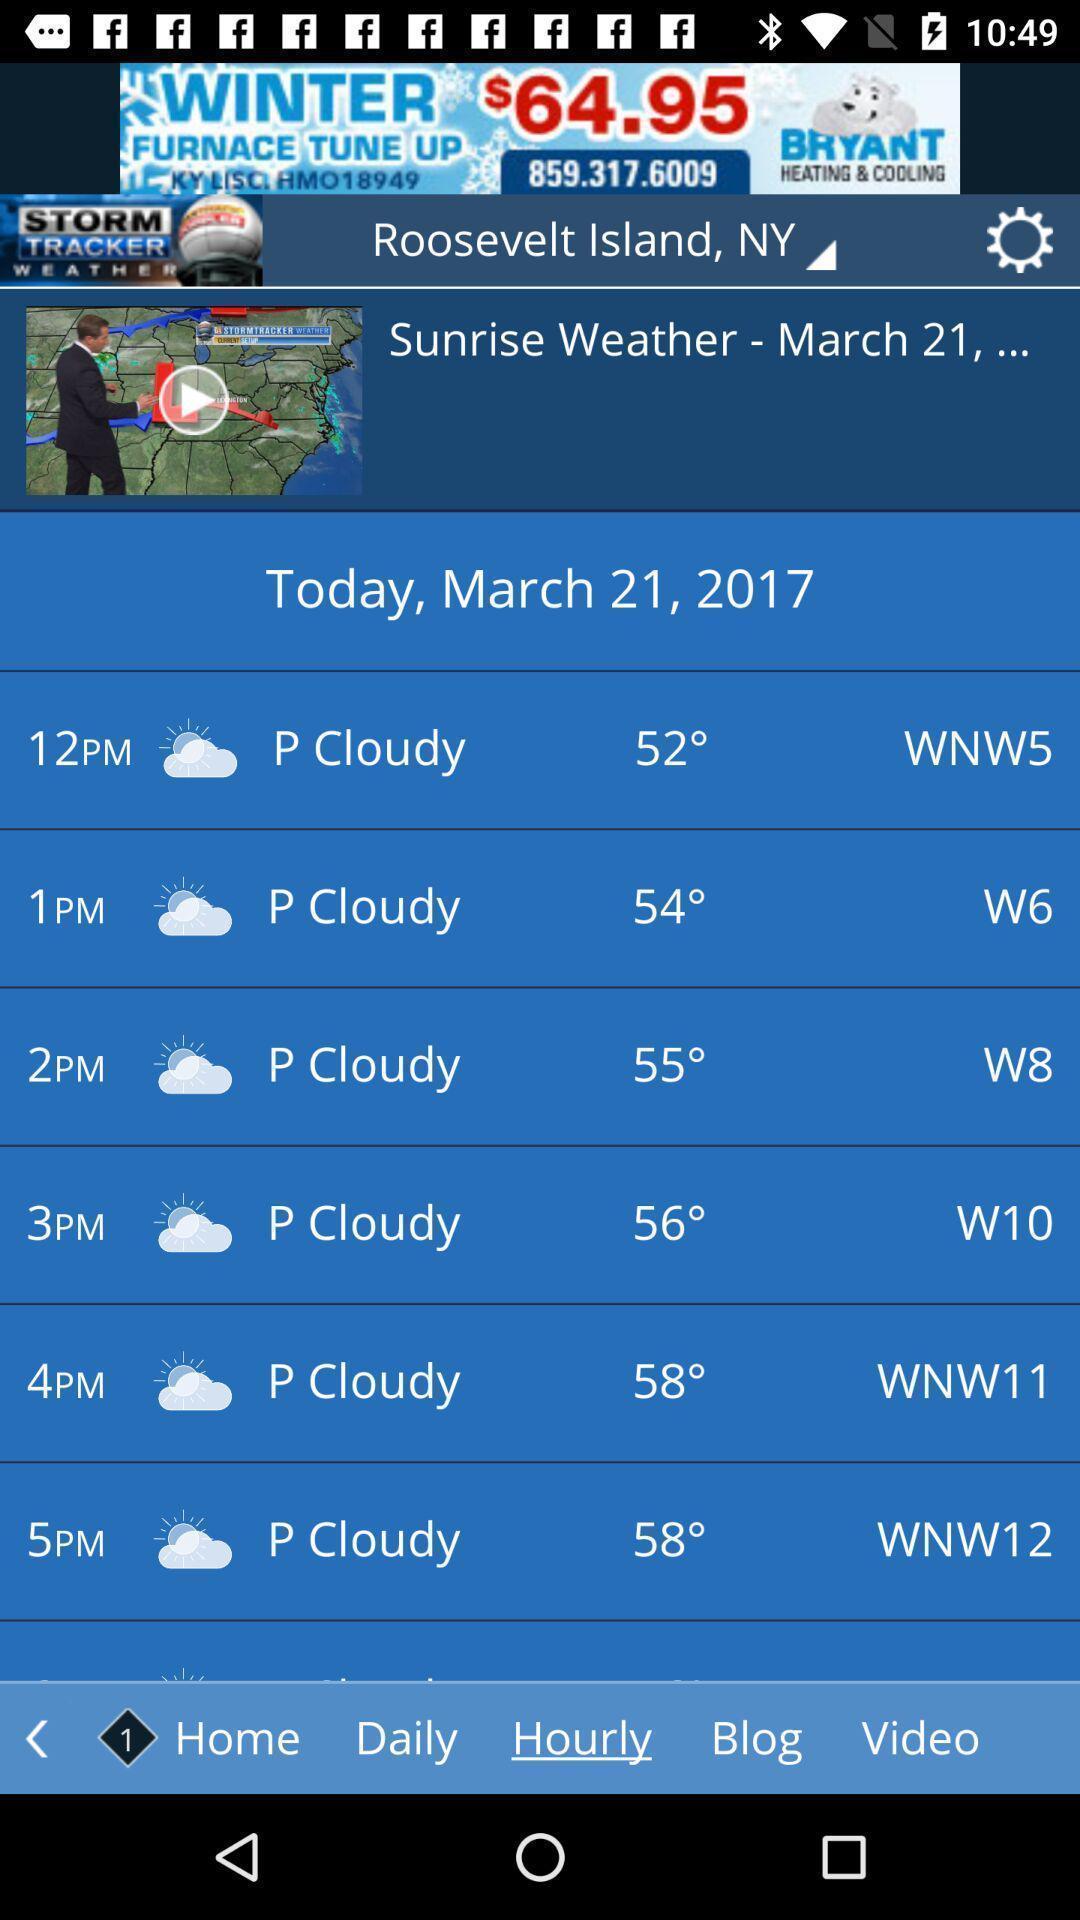Provide a detailed account of this screenshot. Screen showing page of an weather application. 